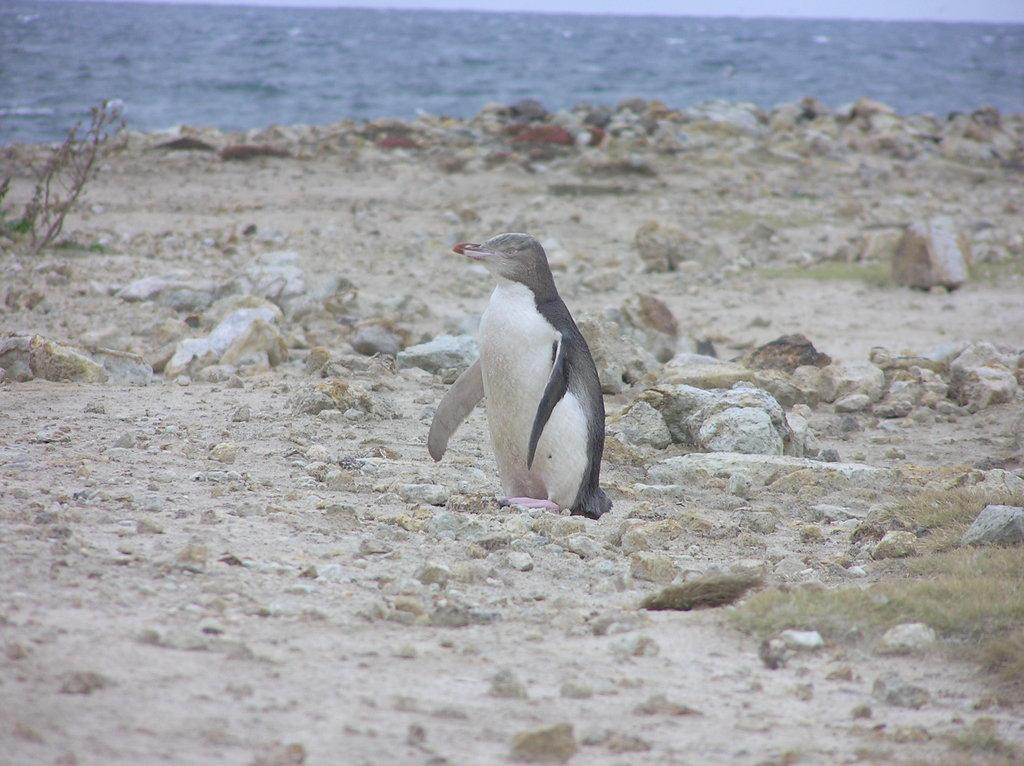What animal is present in the image? There is a penguin in the image. What is the penguin doing in the image? The penguin is standing on the ground. What can be seen in the background of the image? There are stones and water visible in the background of the image. What type of shoe is the penguin wearing in the image? Penguins do not wear shoes, and there is no shoe present in the image. 